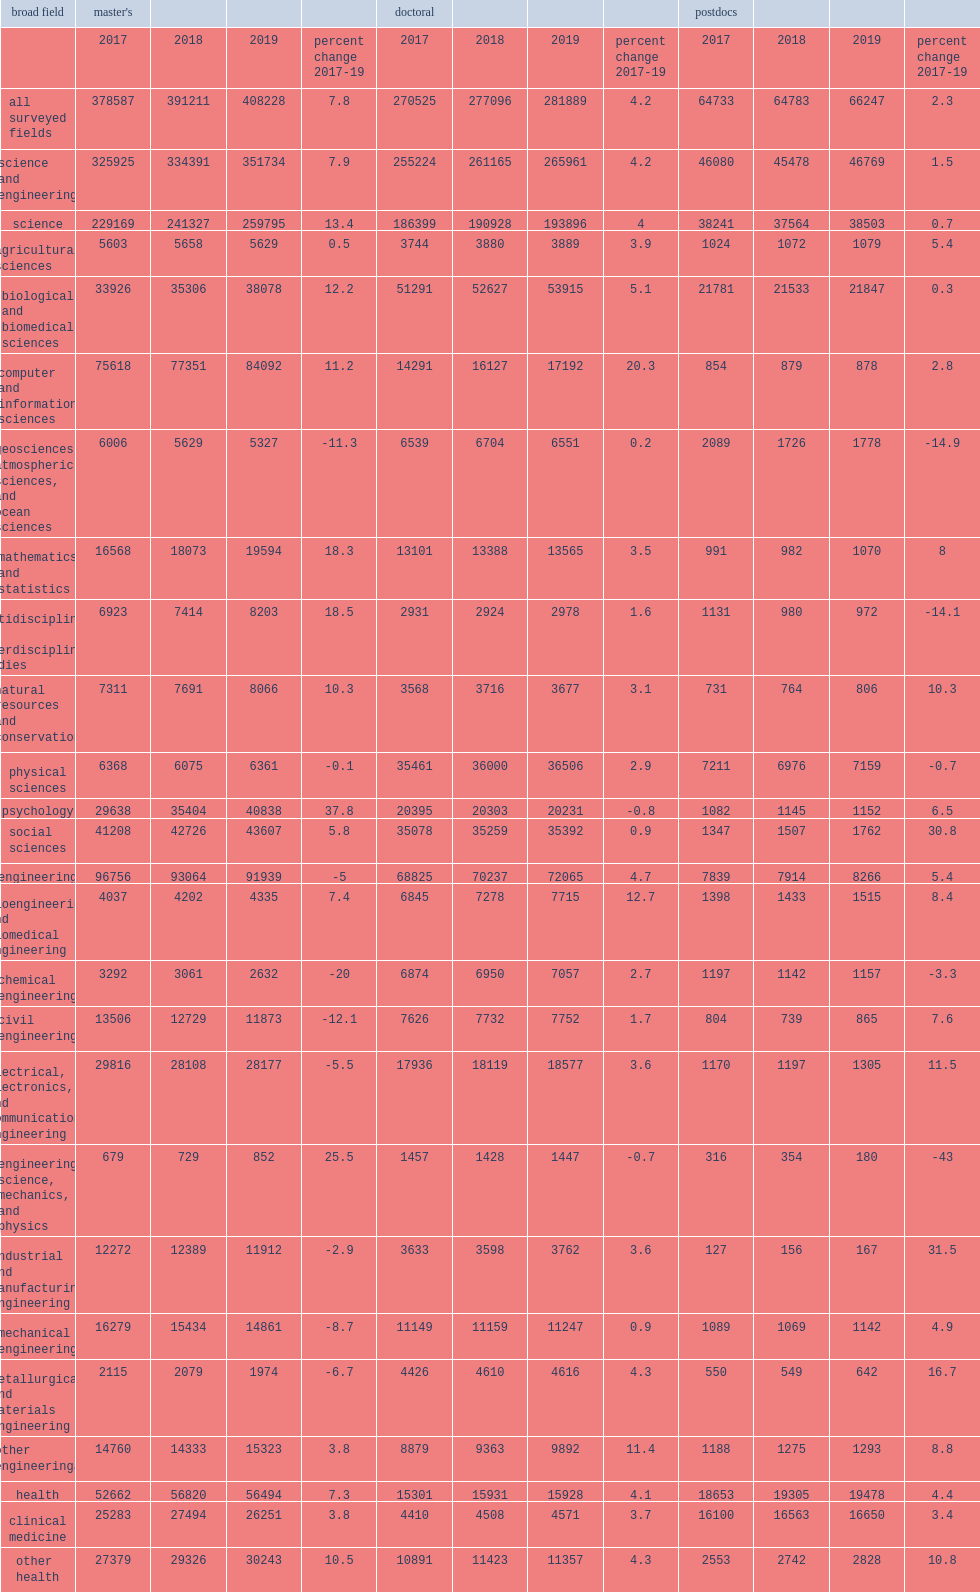In engineering, how many percentage points did master's enrollments decline by? 5. In engineering, how many percentage points did doctoral's enrollments increase by? 4.7. In engineering, how many percentage points did postdocs' enrollments increase by? 5.4. Which broad field led the top five fields of growth among master's science students in enrollment? Psychology. How many percentage points of increase in doctoral enrollment in the sciences? 4.0. How many percent of increase in computer and information sciences students in doctoral enrollment? 20.3. Biological and biomedical sciences, the single largest field of study among doctoral students, how many percentage points of students grew between 2017 and 2019? 5.1. Biological and biomedical sciences, the single largest field of study among doctoral students, how many students grew between 2017 and 2019? 53915.0. Which education of students had the large percentage increase in social sciences? Social sciences. 